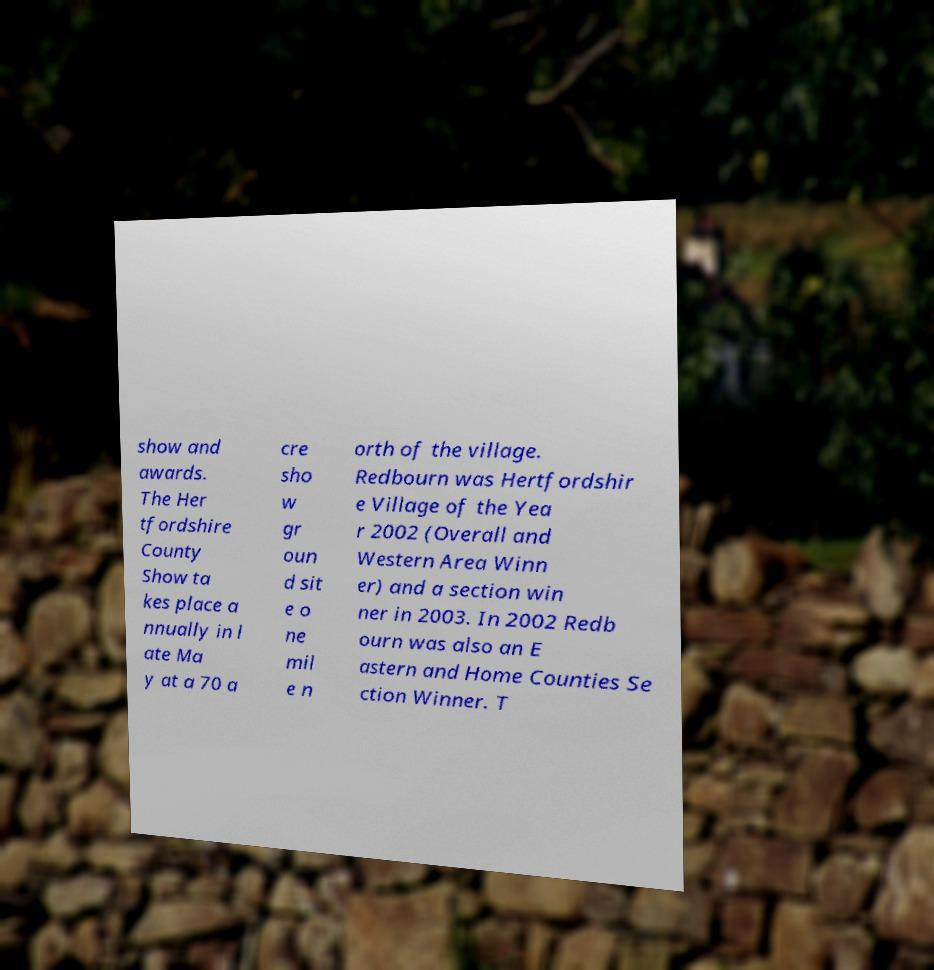Please read and relay the text visible in this image. What does it say? show and awards. The Her tfordshire County Show ta kes place a nnually in l ate Ma y at a 70 a cre sho w gr oun d sit e o ne mil e n orth of the village. Redbourn was Hertfordshir e Village of the Yea r 2002 (Overall and Western Area Winn er) and a section win ner in 2003. In 2002 Redb ourn was also an E astern and Home Counties Se ction Winner. T 